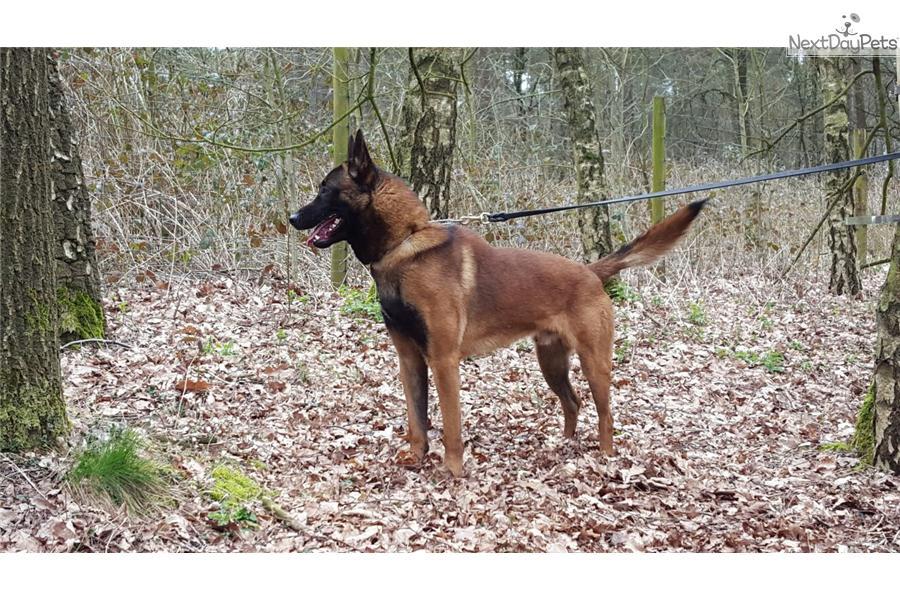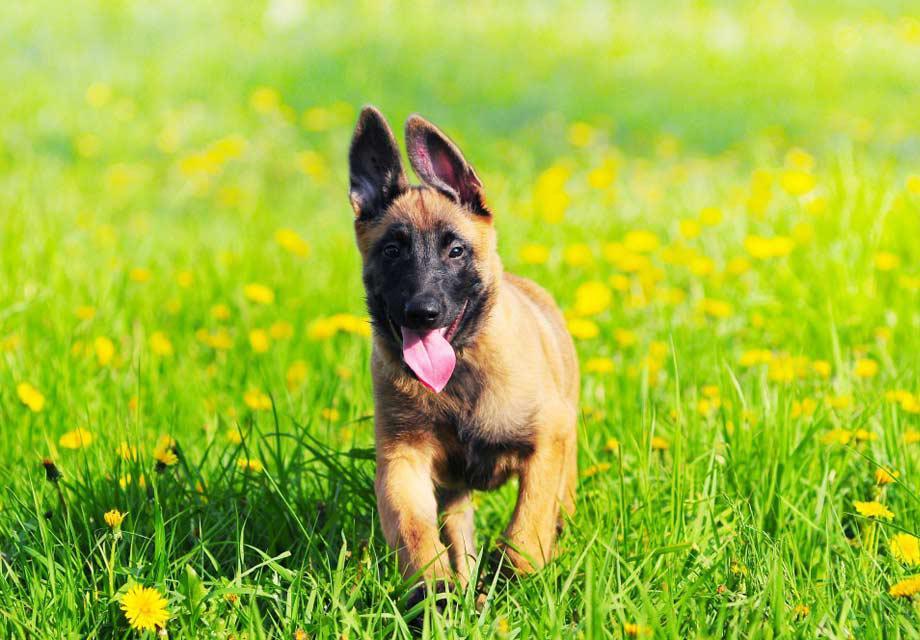The first image is the image on the left, the second image is the image on the right. For the images displayed, is the sentence "A puppy is running through the grass toward the camera." factually correct? Answer yes or no. Yes. The first image is the image on the left, the second image is the image on the right. Analyze the images presented: Is the assertion "At least one dog is wearing a leash." valid? Answer yes or no. Yes. 